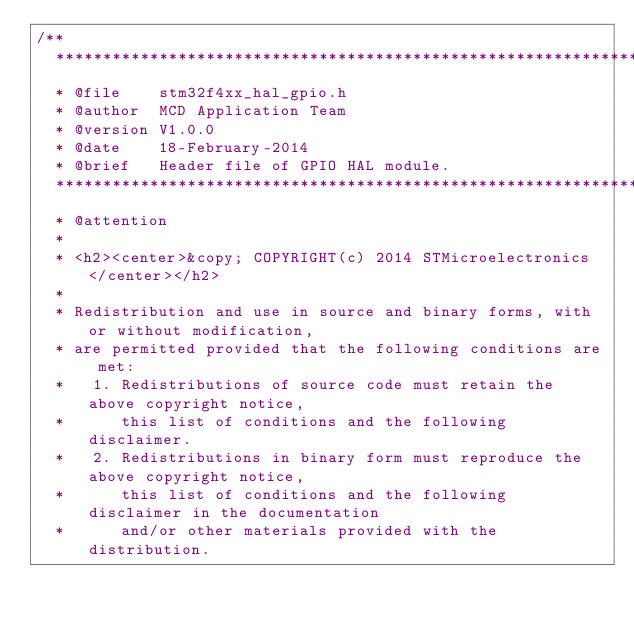<code> <loc_0><loc_0><loc_500><loc_500><_C_>/**
  ******************************************************************************
  * @file    stm32f4xx_hal_gpio.h
  * @author  MCD Application Team
  * @version V1.0.0
  * @date    18-February-2014
  * @brief   Header file of GPIO HAL module.
  ******************************************************************************
  * @attention
  *
  * <h2><center>&copy; COPYRIGHT(c) 2014 STMicroelectronics</center></h2>
  *
  * Redistribution and use in source and binary forms, with or without modification,
  * are permitted provided that the following conditions are met:
  *   1. Redistributions of source code must retain the above copyright notice,
  *      this list of conditions and the following disclaimer.
  *   2. Redistributions in binary form must reproduce the above copyright notice,
  *      this list of conditions and the following disclaimer in the documentation
  *      and/or other materials provided with the distribution.</code> 